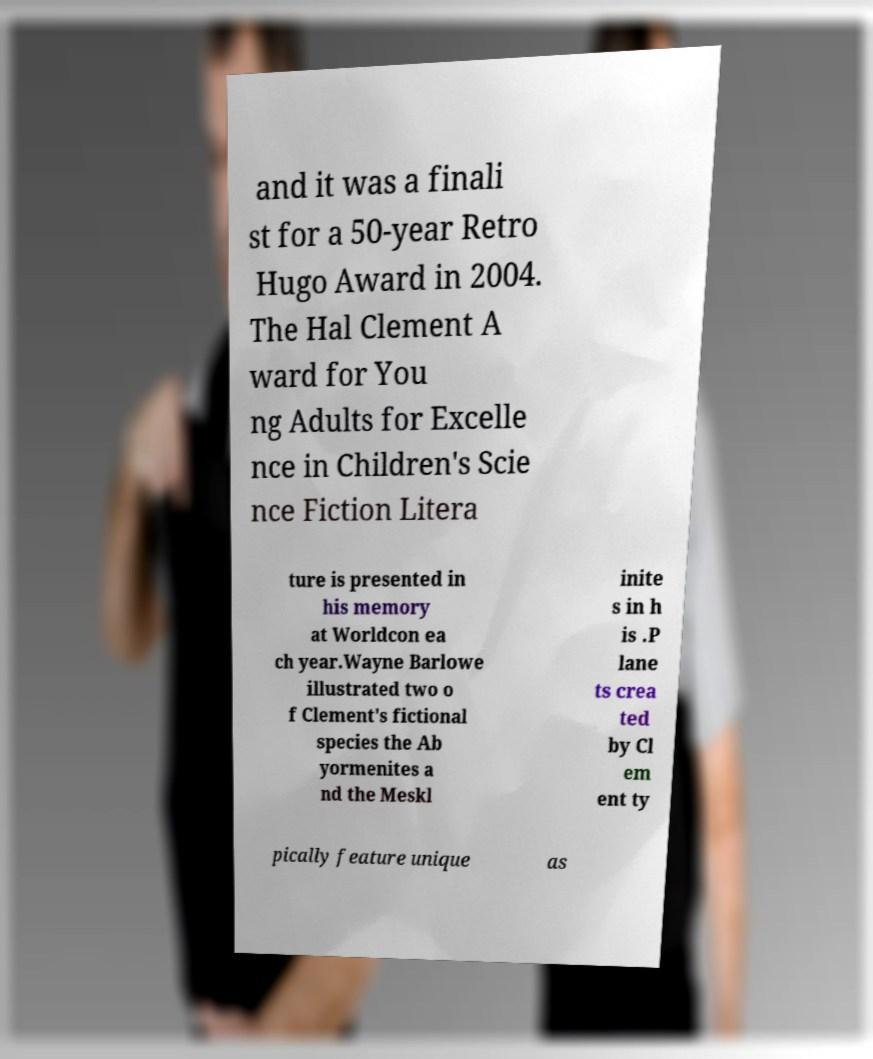Can you accurately transcribe the text from the provided image for me? and it was a finali st for a 50-year Retro Hugo Award in 2004. The Hal Clement A ward for You ng Adults for Excelle nce in Children's Scie nce Fiction Litera ture is presented in his memory at Worldcon ea ch year.Wayne Barlowe illustrated two o f Clement's fictional species the Ab yormenites a nd the Meskl inite s in h is .P lane ts crea ted by Cl em ent ty pically feature unique as 